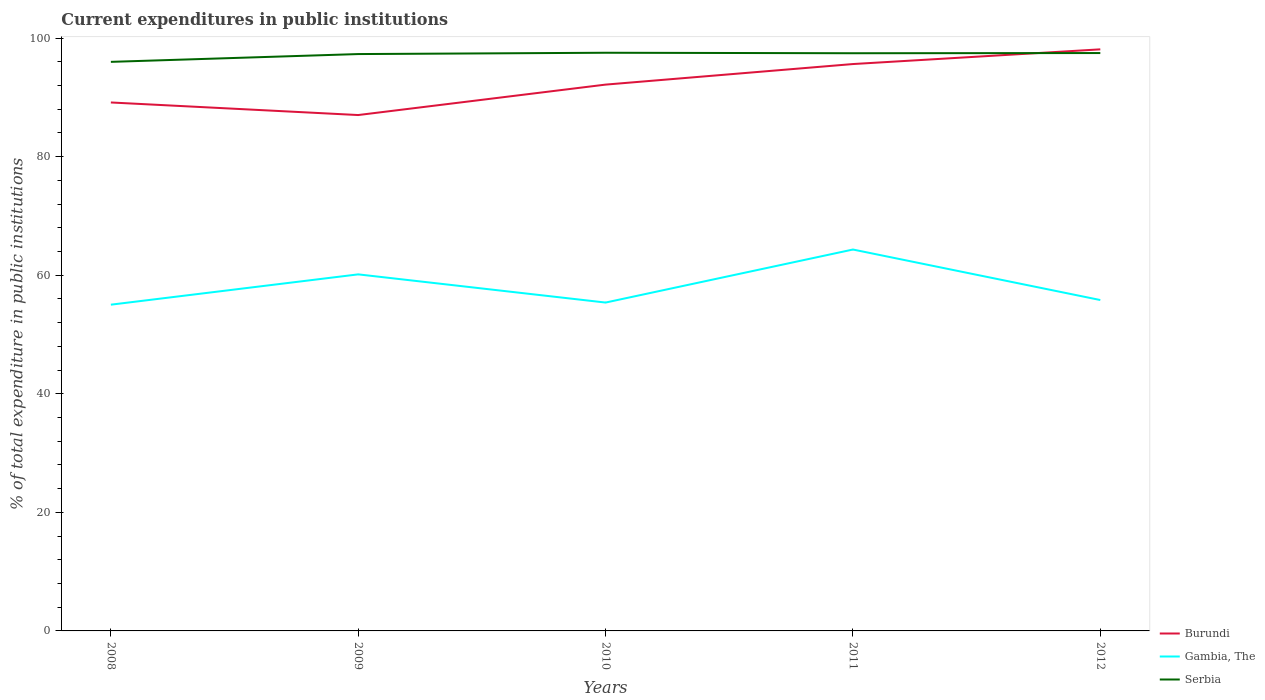How many different coloured lines are there?
Offer a terse response. 3. Does the line corresponding to Serbia intersect with the line corresponding to Burundi?
Ensure brevity in your answer.  Yes. Is the number of lines equal to the number of legend labels?
Your answer should be very brief. Yes. Across all years, what is the maximum current expenditures in public institutions in Burundi?
Your answer should be compact. 87.01. What is the total current expenditures in public institutions in Serbia in the graph?
Your answer should be very brief. -0.22. What is the difference between the highest and the second highest current expenditures in public institutions in Burundi?
Offer a terse response. 11.08. What is the difference between the highest and the lowest current expenditures in public institutions in Serbia?
Your answer should be compact. 4. Is the current expenditures in public institutions in Burundi strictly greater than the current expenditures in public institutions in Serbia over the years?
Provide a short and direct response. No. How many lines are there?
Your answer should be compact. 3. How many years are there in the graph?
Ensure brevity in your answer.  5. Does the graph contain any zero values?
Provide a short and direct response. No. How are the legend labels stacked?
Offer a terse response. Vertical. What is the title of the graph?
Provide a short and direct response. Current expenditures in public institutions. Does "West Bank and Gaza" appear as one of the legend labels in the graph?
Offer a terse response. No. What is the label or title of the Y-axis?
Give a very brief answer. % of total expenditure in public institutions. What is the % of total expenditure in public institutions in Burundi in 2008?
Your answer should be very brief. 89.13. What is the % of total expenditure in public institutions in Gambia, The in 2008?
Give a very brief answer. 55.02. What is the % of total expenditure in public institutions of Serbia in 2008?
Keep it short and to the point. 95.98. What is the % of total expenditure in public institutions in Burundi in 2009?
Offer a terse response. 87.01. What is the % of total expenditure in public institutions in Gambia, The in 2009?
Your response must be concise. 60.14. What is the % of total expenditure in public institutions in Serbia in 2009?
Your answer should be very brief. 97.29. What is the % of total expenditure in public institutions of Burundi in 2010?
Offer a terse response. 92.14. What is the % of total expenditure in public institutions in Gambia, The in 2010?
Give a very brief answer. 55.38. What is the % of total expenditure in public institutions of Serbia in 2010?
Keep it short and to the point. 97.51. What is the % of total expenditure in public institutions in Burundi in 2011?
Offer a terse response. 95.61. What is the % of total expenditure in public institutions of Gambia, The in 2011?
Provide a short and direct response. 64.33. What is the % of total expenditure in public institutions of Serbia in 2011?
Your response must be concise. 97.43. What is the % of total expenditure in public institutions in Burundi in 2012?
Your answer should be compact. 98.09. What is the % of total expenditure in public institutions in Gambia, The in 2012?
Your response must be concise. 55.81. What is the % of total expenditure in public institutions in Serbia in 2012?
Make the answer very short. 97.47. Across all years, what is the maximum % of total expenditure in public institutions in Burundi?
Offer a terse response. 98.09. Across all years, what is the maximum % of total expenditure in public institutions in Gambia, The?
Your answer should be very brief. 64.33. Across all years, what is the maximum % of total expenditure in public institutions in Serbia?
Provide a short and direct response. 97.51. Across all years, what is the minimum % of total expenditure in public institutions of Burundi?
Your answer should be very brief. 87.01. Across all years, what is the minimum % of total expenditure in public institutions in Gambia, The?
Provide a short and direct response. 55.02. Across all years, what is the minimum % of total expenditure in public institutions of Serbia?
Make the answer very short. 95.98. What is the total % of total expenditure in public institutions in Burundi in the graph?
Provide a succinct answer. 461.98. What is the total % of total expenditure in public institutions in Gambia, The in the graph?
Your answer should be compact. 290.68. What is the total % of total expenditure in public institutions in Serbia in the graph?
Make the answer very short. 485.69. What is the difference between the % of total expenditure in public institutions of Burundi in 2008 and that in 2009?
Ensure brevity in your answer.  2.12. What is the difference between the % of total expenditure in public institutions in Gambia, The in 2008 and that in 2009?
Provide a short and direct response. -5.11. What is the difference between the % of total expenditure in public institutions of Serbia in 2008 and that in 2009?
Your answer should be compact. -1.31. What is the difference between the % of total expenditure in public institutions of Burundi in 2008 and that in 2010?
Your response must be concise. -3.01. What is the difference between the % of total expenditure in public institutions of Gambia, The in 2008 and that in 2010?
Ensure brevity in your answer.  -0.36. What is the difference between the % of total expenditure in public institutions of Serbia in 2008 and that in 2010?
Your answer should be very brief. -1.53. What is the difference between the % of total expenditure in public institutions of Burundi in 2008 and that in 2011?
Provide a succinct answer. -6.48. What is the difference between the % of total expenditure in public institutions of Gambia, The in 2008 and that in 2011?
Offer a very short reply. -9.3. What is the difference between the % of total expenditure in public institutions in Serbia in 2008 and that in 2011?
Offer a terse response. -1.45. What is the difference between the % of total expenditure in public institutions in Burundi in 2008 and that in 2012?
Give a very brief answer. -8.96. What is the difference between the % of total expenditure in public institutions of Gambia, The in 2008 and that in 2012?
Provide a short and direct response. -0.78. What is the difference between the % of total expenditure in public institutions of Serbia in 2008 and that in 2012?
Keep it short and to the point. -1.49. What is the difference between the % of total expenditure in public institutions of Burundi in 2009 and that in 2010?
Give a very brief answer. -5.13. What is the difference between the % of total expenditure in public institutions in Gambia, The in 2009 and that in 2010?
Provide a succinct answer. 4.75. What is the difference between the % of total expenditure in public institutions in Serbia in 2009 and that in 2010?
Give a very brief answer. -0.22. What is the difference between the % of total expenditure in public institutions in Burundi in 2009 and that in 2011?
Give a very brief answer. -8.6. What is the difference between the % of total expenditure in public institutions in Gambia, The in 2009 and that in 2011?
Give a very brief answer. -4.19. What is the difference between the % of total expenditure in public institutions of Serbia in 2009 and that in 2011?
Give a very brief answer. -0.14. What is the difference between the % of total expenditure in public institutions in Burundi in 2009 and that in 2012?
Offer a terse response. -11.08. What is the difference between the % of total expenditure in public institutions in Gambia, The in 2009 and that in 2012?
Your answer should be compact. 4.33. What is the difference between the % of total expenditure in public institutions in Serbia in 2009 and that in 2012?
Your answer should be very brief. -0.17. What is the difference between the % of total expenditure in public institutions of Burundi in 2010 and that in 2011?
Ensure brevity in your answer.  -3.47. What is the difference between the % of total expenditure in public institutions of Gambia, The in 2010 and that in 2011?
Your response must be concise. -8.94. What is the difference between the % of total expenditure in public institutions of Serbia in 2010 and that in 2011?
Your response must be concise. 0.08. What is the difference between the % of total expenditure in public institutions in Burundi in 2010 and that in 2012?
Give a very brief answer. -5.95. What is the difference between the % of total expenditure in public institutions of Gambia, The in 2010 and that in 2012?
Make the answer very short. -0.42. What is the difference between the % of total expenditure in public institutions in Serbia in 2010 and that in 2012?
Give a very brief answer. 0.05. What is the difference between the % of total expenditure in public institutions of Burundi in 2011 and that in 2012?
Your answer should be compact. -2.48. What is the difference between the % of total expenditure in public institutions of Gambia, The in 2011 and that in 2012?
Your answer should be very brief. 8.52. What is the difference between the % of total expenditure in public institutions of Serbia in 2011 and that in 2012?
Your answer should be very brief. -0.03. What is the difference between the % of total expenditure in public institutions of Burundi in 2008 and the % of total expenditure in public institutions of Gambia, The in 2009?
Ensure brevity in your answer.  28.99. What is the difference between the % of total expenditure in public institutions in Burundi in 2008 and the % of total expenditure in public institutions in Serbia in 2009?
Your answer should be compact. -8.16. What is the difference between the % of total expenditure in public institutions of Gambia, The in 2008 and the % of total expenditure in public institutions of Serbia in 2009?
Provide a short and direct response. -42.27. What is the difference between the % of total expenditure in public institutions in Burundi in 2008 and the % of total expenditure in public institutions in Gambia, The in 2010?
Make the answer very short. 33.75. What is the difference between the % of total expenditure in public institutions of Burundi in 2008 and the % of total expenditure in public institutions of Serbia in 2010?
Give a very brief answer. -8.38. What is the difference between the % of total expenditure in public institutions in Gambia, The in 2008 and the % of total expenditure in public institutions in Serbia in 2010?
Your response must be concise. -42.49. What is the difference between the % of total expenditure in public institutions in Burundi in 2008 and the % of total expenditure in public institutions in Gambia, The in 2011?
Your answer should be very brief. 24.8. What is the difference between the % of total expenditure in public institutions in Burundi in 2008 and the % of total expenditure in public institutions in Serbia in 2011?
Your answer should be very brief. -8.3. What is the difference between the % of total expenditure in public institutions in Gambia, The in 2008 and the % of total expenditure in public institutions in Serbia in 2011?
Offer a terse response. -42.41. What is the difference between the % of total expenditure in public institutions in Burundi in 2008 and the % of total expenditure in public institutions in Gambia, The in 2012?
Provide a short and direct response. 33.32. What is the difference between the % of total expenditure in public institutions of Burundi in 2008 and the % of total expenditure in public institutions of Serbia in 2012?
Ensure brevity in your answer.  -8.34. What is the difference between the % of total expenditure in public institutions in Gambia, The in 2008 and the % of total expenditure in public institutions in Serbia in 2012?
Your answer should be compact. -42.44. What is the difference between the % of total expenditure in public institutions of Burundi in 2009 and the % of total expenditure in public institutions of Gambia, The in 2010?
Make the answer very short. 31.63. What is the difference between the % of total expenditure in public institutions of Burundi in 2009 and the % of total expenditure in public institutions of Serbia in 2010?
Offer a terse response. -10.51. What is the difference between the % of total expenditure in public institutions of Gambia, The in 2009 and the % of total expenditure in public institutions of Serbia in 2010?
Keep it short and to the point. -37.38. What is the difference between the % of total expenditure in public institutions of Burundi in 2009 and the % of total expenditure in public institutions of Gambia, The in 2011?
Make the answer very short. 22.68. What is the difference between the % of total expenditure in public institutions of Burundi in 2009 and the % of total expenditure in public institutions of Serbia in 2011?
Your response must be concise. -10.42. What is the difference between the % of total expenditure in public institutions of Gambia, The in 2009 and the % of total expenditure in public institutions of Serbia in 2011?
Provide a short and direct response. -37.3. What is the difference between the % of total expenditure in public institutions in Burundi in 2009 and the % of total expenditure in public institutions in Gambia, The in 2012?
Keep it short and to the point. 31.2. What is the difference between the % of total expenditure in public institutions in Burundi in 2009 and the % of total expenditure in public institutions in Serbia in 2012?
Ensure brevity in your answer.  -10.46. What is the difference between the % of total expenditure in public institutions of Gambia, The in 2009 and the % of total expenditure in public institutions of Serbia in 2012?
Ensure brevity in your answer.  -37.33. What is the difference between the % of total expenditure in public institutions of Burundi in 2010 and the % of total expenditure in public institutions of Gambia, The in 2011?
Provide a short and direct response. 27.82. What is the difference between the % of total expenditure in public institutions of Burundi in 2010 and the % of total expenditure in public institutions of Serbia in 2011?
Make the answer very short. -5.29. What is the difference between the % of total expenditure in public institutions of Gambia, The in 2010 and the % of total expenditure in public institutions of Serbia in 2011?
Your response must be concise. -42.05. What is the difference between the % of total expenditure in public institutions in Burundi in 2010 and the % of total expenditure in public institutions in Gambia, The in 2012?
Give a very brief answer. 36.34. What is the difference between the % of total expenditure in public institutions in Burundi in 2010 and the % of total expenditure in public institutions in Serbia in 2012?
Your answer should be very brief. -5.32. What is the difference between the % of total expenditure in public institutions of Gambia, The in 2010 and the % of total expenditure in public institutions of Serbia in 2012?
Keep it short and to the point. -42.08. What is the difference between the % of total expenditure in public institutions of Burundi in 2011 and the % of total expenditure in public institutions of Gambia, The in 2012?
Provide a succinct answer. 39.8. What is the difference between the % of total expenditure in public institutions in Burundi in 2011 and the % of total expenditure in public institutions in Serbia in 2012?
Your answer should be very brief. -1.86. What is the difference between the % of total expenditure in public institutions in Gambia, The in 2011 and the % of total expenditure in public institutions in Serbia in 2012?
Your response must be concise. -33.14. What is the average % of total expenditure in public institutions of Burundi per year?
Provide a succinct answer. 92.4. What is the average % of total expenditure in public institutions in Gambia, The per year?
Make the answer very short. 58.14. What is the average % of total expenditure in public institutions of Serbia per year?
Ensure brevity in your answer.  97.14. In the year 2008, what is the difference between the % of total expenditure in public institutions of Burundi and % of total expenditure in public institutions of Gambia, The?
Keep it short and to the point. 34.11. In the year 2008, what is the difference between the % of total expenditure in public institutions in Burundi and % of total expenditure in public institutions in Serbia?
Your response must be concise. -6.85. In the year 2008, what is the difference between the % of total expenditure in public institutions in Gambia, The and % of total expenditure in public institutions in Serbia?
Offer a terse response. -40.96. In the year 2009, what is the difference between the % of total expenditure in public institutions of Burundi and % of total expenditure in public institutions of Gambia, The?
Keep it short and to the point. 26.87. In the year 2009, what is the difference between the % of total expenditure in public institutions in Burundi and % of total expenditure in public institutions in Serbia?
Ensure brevity in your answer.  -10.28. In the year 2009, what is the difference between the % of total expenditure in public institutions in Gambia, The and % of total expenditure in public institutions in Serbia?
Give a very brief answer. -37.16. In the year 2010, what is the difference between the % of total expenditure in public institutions of Burundi and % of total expenditure in public institutions of Gambia, The?
Keep it short and to the point. 36.76. In the year 2010, what is the difference between the % of total expenditure in public institutions of Burundi and % of total expenditure in public institutions of Serbia?
Give a very brief answer. -5.37. In the year 2010, what is the difference between the % of total expenditure in public institutions of Gambia, The and % of total expenditure in public institutions of Serbia?
Ensure brevity in your answer.  -42.13. In the year 2011, what is the difference between the % of total expenditure in public institutions of Burundi and % of total expenditure in public institutions of Gambia, The?
Provide a short and direct response. 31.28. In the year 2011, what is the difference between the % of total expenditure in public institutions in Burundi and % of total expenditure in public institutions in Serbia?
Your response must be concise. -1.82. In the year 2011, what is the difference between the % of total expenditure in public institutions in Gambia, The and % of total expenditure in public institutions in Serbia?
Your response must be concise. -33.11. In the year 2012, what is the difference between the % of total expenditure in public institutions of Burundi and % of total expenditure in public institutions of Gambia, The?
Make the answer very short. 42.28. In the year 2012, what is the difference between the % of total expenditure in public institutions of Burundi and % of total expenditure in public institutions of Serbia?
Give a very brief answer. 0.62. In the year 2012, what is the difference between the % of total expenditure in public institutions of Gambia, The and % of total expenditure in public institutions of Serbia?
Make the answer very short. -41.66. What is the ratio of the % of total expenditure in public institutions of Burundi in 2008 to that in 2009?
Give a very brief answer. 1.02. What is the ratio of the % of total expenditure in public institutions of Gambia, The in 2008 to that in 2009?
Give a very brief answer. 0.92. What is the ratio of the % of total expenditure in public institutions in Serbia in 2008 to that in 2009?
Your answer should be compact. 0.99. What is the ratio of the % of total expenditure in public institutions of Burundi in 2008 to that in 2010?
Your response must be concise. 0.97. What is the ratio of the % of total expenditure in public institutions of Gambia, The in 2008 to that in 2010?
Offer a very short reply. 0.99. What is the ratio of the % of total expenditure in public institutions in Serbia in 2008 to that in 2010?
Your answer should be very brief. 0.98. What is the ratio of the % of total expenditure in public institutions in Burundi in 2008 to that in 2011?
Offer a terse response. 0.93. What is the ratio of the % of total expenditure in public institutions of Gambia, The in 2008 to that in 2011?
Provide a succinct answer. 0.86. What is the ratio of the % of total expenditure in public institutions in Serbia in 2008 to that in 2011?
Ensure brevity in your answer.  0.99. What is the ratio of the % of total expenditure in public institutions in Burundi in 2008 to that in 2012?
Give a very brief answer. 0.91. What is the ratio of the % of total expenditure in public institutions in Gambia, The in 2008 to that in 2012?
Offer a very short reply. 0.99. What is the ratio of the % of total expenditure in public institutions in Serbia in 2008 to that in 2012?
Your answer should be compact. 0.98. What is the ratio of the % of total expenditure in public institutions in Burundi in 2009 to that in 2010?
Provide a short and direct response. 0.94. What is the ratio of the % of total expenditure in public institutions of Gambia, The in 2009 to that in 2010?
Keep it short and to the point. 1.09. What is the ratio of the % of total expenditure in public institutions in Burundi in 2009 to that in 2011?
Your response must be concise. 0.91. What is the ratio of the % of total expenditure in public institutions in Gambia, The in 2009 to that in 2011?
Give a very brief answer. 0.93. What is the ratio of the % of total expenditure in public institutions of Serbia in 2009 to that in 2011?
Provide a succinct answer. 1. What is the ratio of the % of total expenditure in public institutions of Burundi in 2009 to that in 2012?
Offer a terse response. 0.89. What is the ratio of the % of total expenditure in public institutions in Gambia, The in 2009 to that in 2012?
Your response must be concise. 1.08. What is the ratio of the % of total expenditure in public institutions of Serbia in 2009 to that in 2012?
Keep it short and to the point. 1. What is the ratio of the % of total expenditure in public institutions in Burundi in 2010 to that in 2011?
Offer a very short reply. 0.96. What is the ratio of the % of total expenditure in public institutions in Gambia, The in 2010 to that in 2011?
Provide a short and direct response. 0.86. What is the ratio of the % of total expenditure in public institutions in Serbia in 2010 to that in 2011?
Your answer should be compact. 1. What is the ratio of the % of total expenditure in public institutions in Burundi in 2010 to that in 2012?
Your answer should be compact. 0.94. What is the ratio of the % of total expenditure in public institutions of Gambia, The in 2010 to that in 2012?
Ensure brevity in your answer.  0.99. What is the ratio of the % of total expenditure in public institutions in Serbia in 2010 to that in 2012?
Give a very brief answer. 1. What is the ratio of the % of total expenditure in public institutions of Burundi in 2011 to that in 2012?
Give a very brief answer. 0.97. What is the ratio of the % of total expenditure in public institutions in Gambia, The in 2011 to that in 2012?
Provide a succinct answer. 1.15. What is the difference between the highest and the second highest % of total expenditure in public institutions of Burundi?
Offer a terse response. 2.48. What is the difference between the highest and the second highest % of total expenditure in public institutions of Gambia, The?
Ensure brevity in your answer.  4.19. What is the difference between the highest and the second highest % of total expenditure in public institutions in Serbia?
Make the answer very short. 0.05. What is the difference between the highest and the lowest % of total expenditure in public institutions in Burundi?
Give a very brief answer. 11.08. What is the difference between the highest and the lowest % of total expenditure in public institutions in Gambia, The?
Your response must be concise. 9.3. What is the difference between the highest and the lowest % of total expenditure in public institutions in Serbia?
Give a very brief answer. 1.53. 